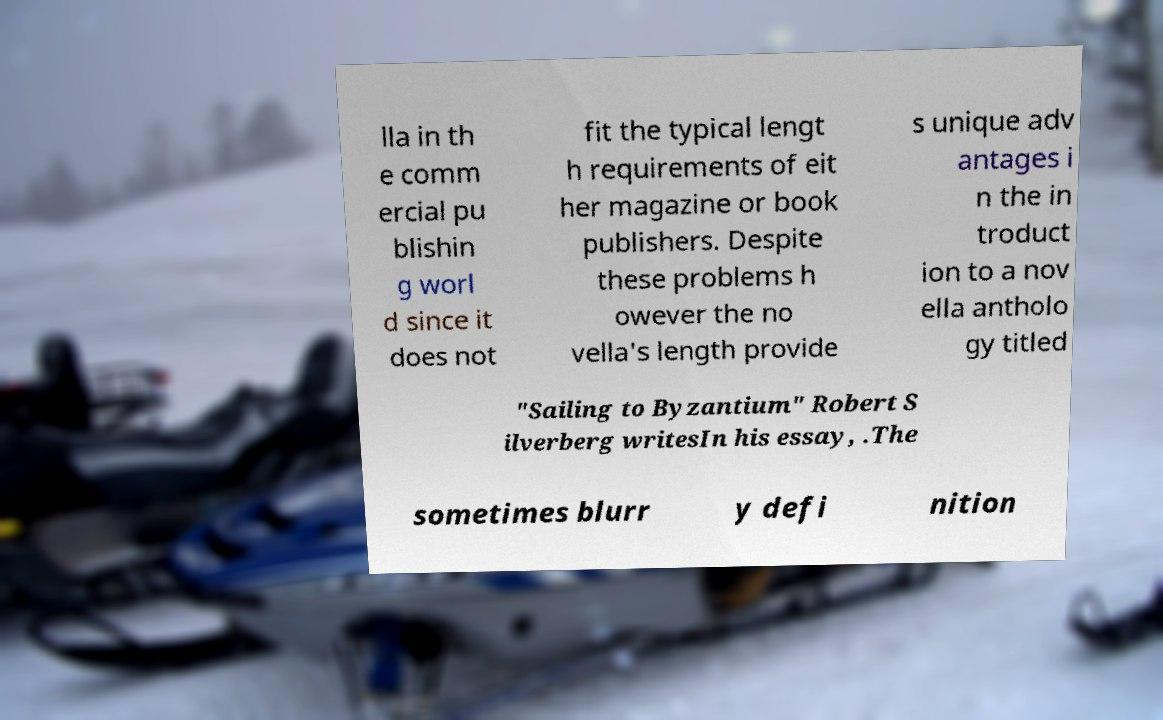For documentation purposes, I need the text within this image transcribed. Could you provide that? lla in th e comm ercial pu blishin g worl d since it does not fit the typical lengt h requirements of eit her magazine or book publishers. Despite these problems h owever the no vella's length provide s unique adv antages i n the in troduct ion to a nov ella antholo gy titled "Sailing to Byzantium" Robert S ilverberg writesIn his essay, .The sometimes blurr y defi nition 